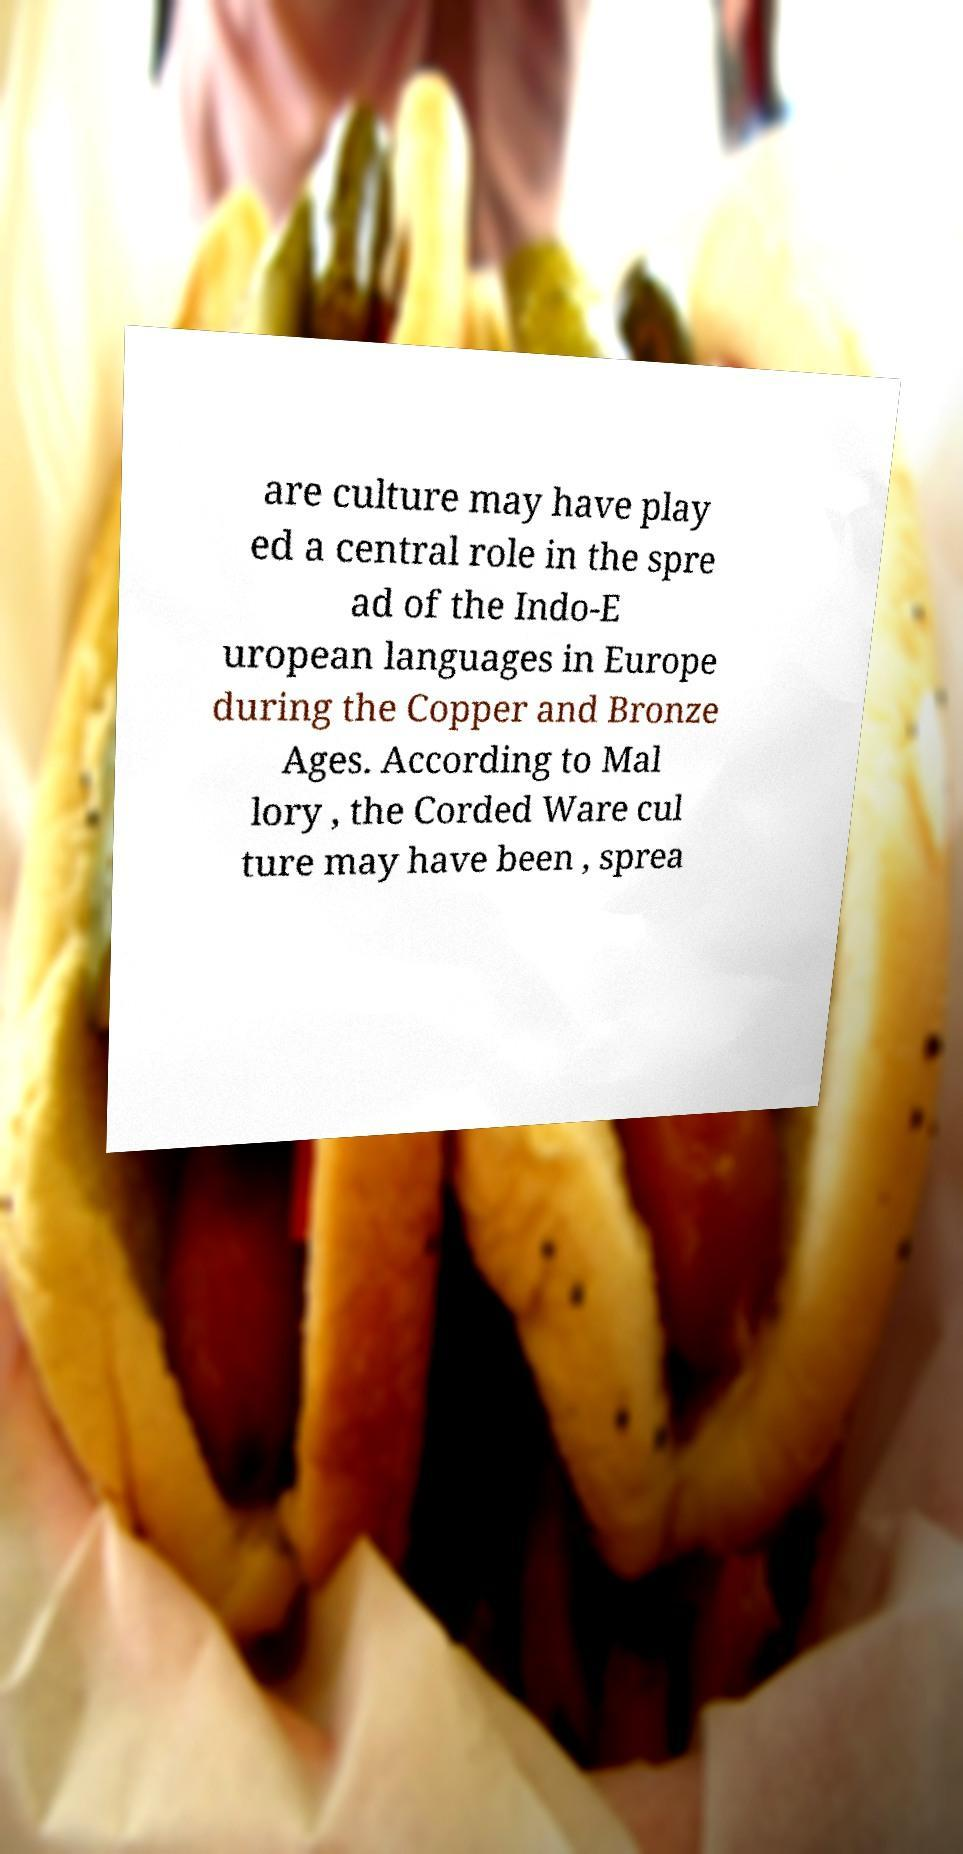Can you accurately transcribe the text from the provided image for me? are culture may have play ed a central role in the spre ad of the Indo-E uropean languages in Europe during the Copper and Bronze Ages. According to Mal lory , the Corded Ware cul ture may have been , sprea 